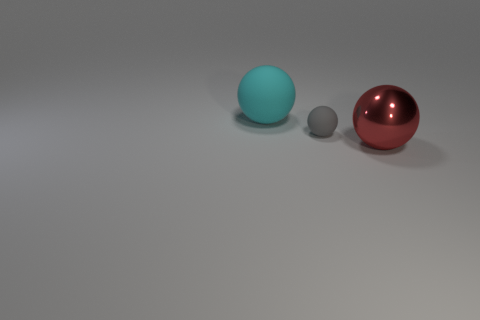Is there any other thing that has the same size as the gray ball?
Offer a very short reply. No. The thing that is both in front of the large cyan rubber object and left of the large red metal ball is made of what material?
Ensure brevity in your answer.  Rubber. What shape is the matte thing that is behind the small gray object?
Your answer should be very brief. Sphere. What is the shape of the big thing on the left side of the big thing in front of the large cyan matte thing?
Your response must be concise. Sphere. Are there any matte objects of the same shape as the red shiny object?
Your answer should be compact. Yes. What shape is the red object that is the same size as the cyan rubber sphere?
Provide a short and direct response. Sphere. Are there any spheres in front of the matte object in front of the large ball behind the small thing?
Your answer should be compact. Yes. Are there any blue metal cubes that have the same size as the gray matte object?
Your answer should be very brief. No. How big is the thing that is to the right of the small gray sphere?
Offer a very short reply. Large. There is a large ball behind the big object that is to the right of the large object on the left side of the red metal sphere; what color is it?
Offer a terse response. Cyan. 